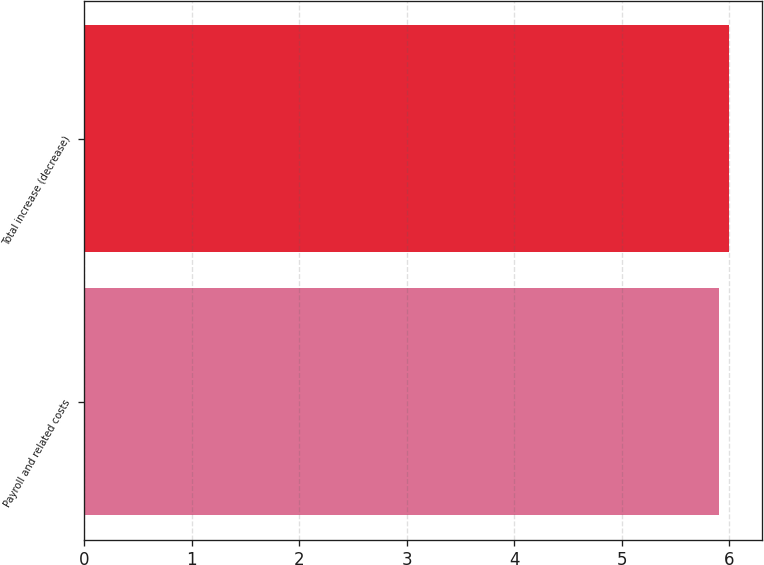<chart> <loc_0><loc_0><loc_500><loc_500><bar_chart><fcel>Payroll and related costs<fcel>Total increase (decrease)<nl><fcel>5.9<fcel>6<nl></chart> 